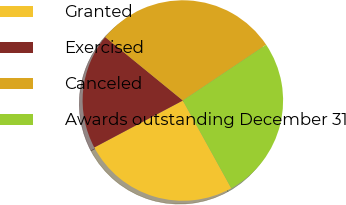Convert chart. <chart><loc_0><loc_0><loc_500><loc_500><pie_chart><fcel>Granted<fcel>Exercised<fcel>Canceled<fcel>Awards outstanding December 31<nl><fcel>25.27%<fcel>18.66%<fcel>29.7%<fcel>26.37%<nl></chart> 